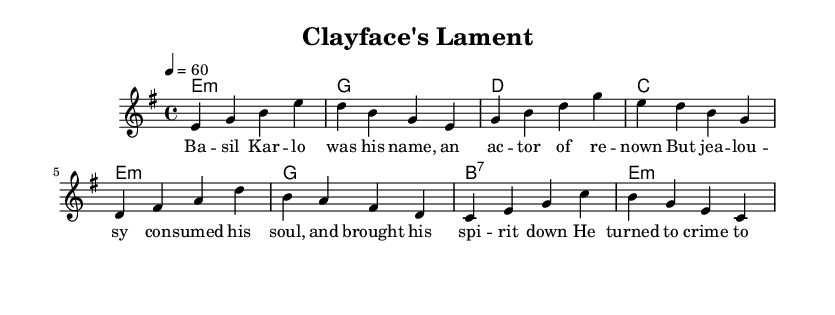What is the key signature of this music? The key signature shows E minor, which is identified by one sharp (F#). This can usually be seen at the beginning of the staff or indicated beside it.
Answer: E minor What is the time signature of this music? This is indicated by the 4/4 notation that appears at the beginning of the staff, showing that there are four beats in each measure and the quarter note gets one beat.
Answer: 4/4 What is the tempo marking of this piece? The tempo marking is given as 4 = 60, which specifies that the quarter note should be played at a speed of 60 beats per minute.
Answer: 60 Which character's origin story is told in the lyrics? The lyrics mention Basil Karlo, who is known as Clayface, focusing on his background and transformation into a villain.
Answer: Basil Karlo How many measures are in the melody? By counting visually from the start of the melody to the end, we can see there are eight measures present in this section.
Answer: Eight What type of AAB structure does this music follow? The lyrics present a clear narrative structure where the first two lines introduce the character, and the third and fourth lines conclude the tale, following the AAB blues format.
Answer: AAB 